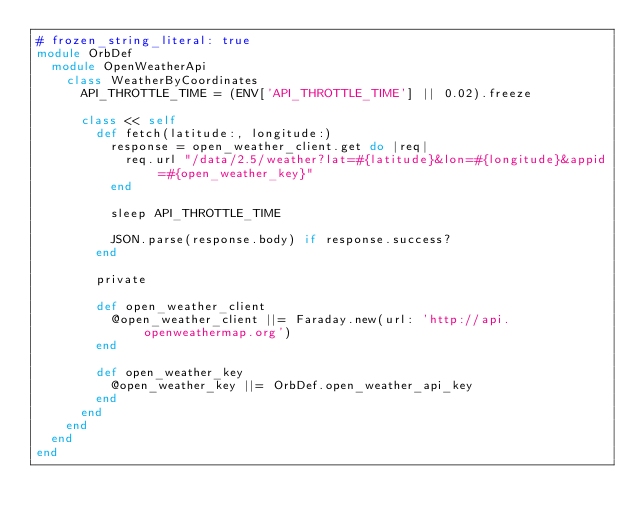<code> <loc_0><loc_0><loc_500><loc_500><_Ruby_># frozen_string_literal: true
module OrbDef
  module OpenWeatherApi
    class WeatherByCoordinates
      API_THROTTLE_TIME = (ENV['API_THROTTLE_TIME'] || 0.02).freeze

      class << self
        def fetch(latitude:, longitude:)
          response = open_weather_client.get do |req|
            req.url "/data/2.5/weather?lat=#{latitude}&lon=#{longitude}&appid=#{open_weather_key}"
          end

          sleep API_THROTTLE_TIME

          JSON.parse(response.body) if response.success?
        end

        private

        def open_weather_client
          @open_weather_client ||= Faraday.new(url: 'http://api.openweathermap.org')
        end

        def open_weather_key
          @open_weather_key ||= OrbDef.open_weather_api_key
        end
      end
    end
  end
end

</code> 